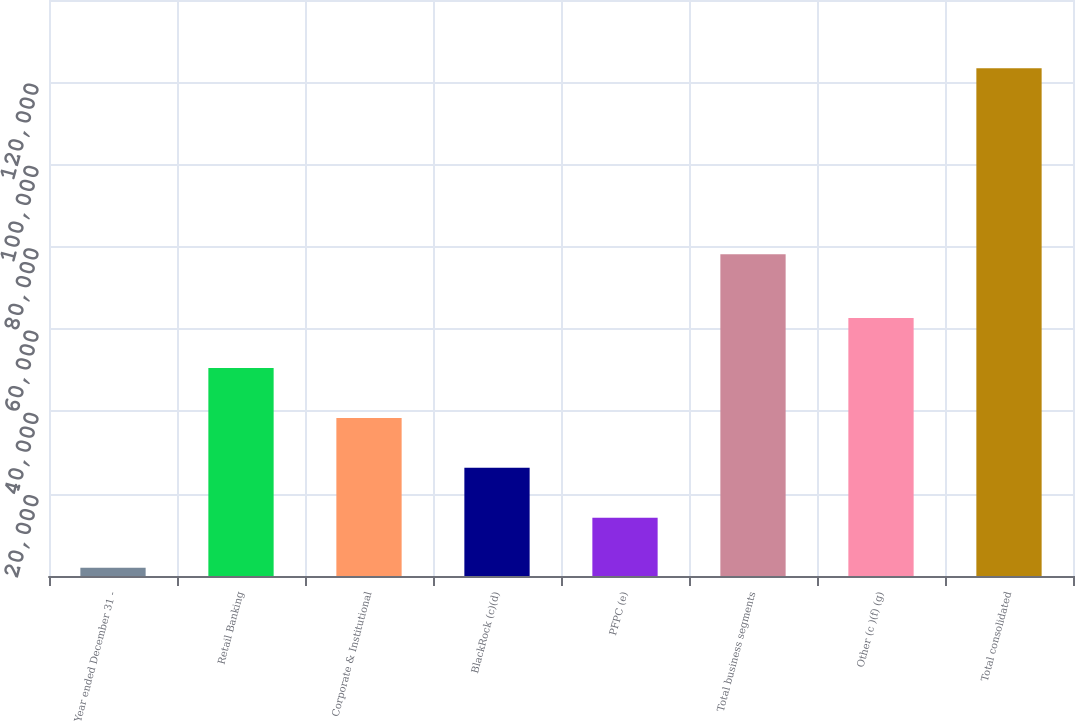<chart> <loc_0><loc_0><loc_500><loc_500><bar_chart><fcel>Year ended December 31 -<fcel>Retail Banking<fcel>Corporate & Institutional<fcel>BlackRock (c)(d)<fcel>PFPC (e)<fcel>Total business segments<fcel>Other (c )(f) (g)<fcel>Total consolidated<nl><fcel>2007<fcel>50571.4<fcel>38430.3<fcel>26289.2<fcel>14148.1<fcel>78211<fcel>62712.5<fcel>123418<nl></chart> 